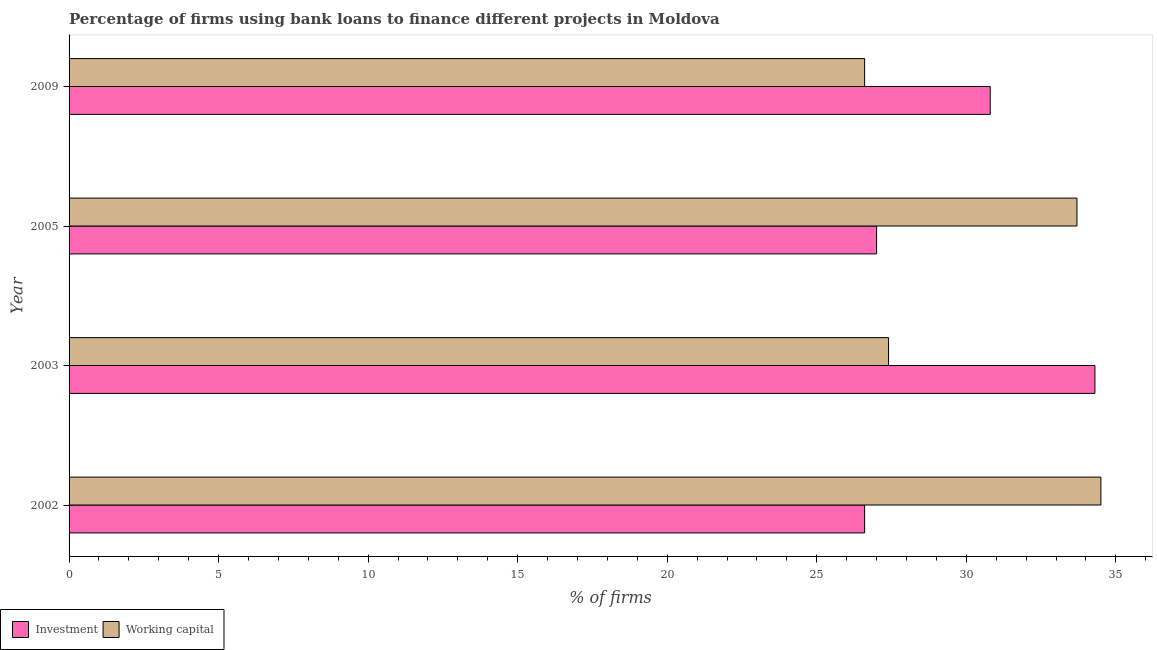How many groups of bars are there?
Offer a terse response. 4. How many bars are there on the 4th tick from the top?
Provide a short and direct response. 2. How many bars are there on the 1st tick from the bottom?
Give a very brief answer. 2. What is the label of the 2nd group of bars from the top?
Give a very brief answer. 2005. What is the percentage of firms using banks to finance working capital in 2002?
Make the answer very short. 34.5. Across all years, what is the maximum percentage of firms using banks to finance working capital?
Offer a very short reply. 34.5. Across all years, what is the minimum percentage of firms using banks to finance investment?
Offer a terse response. 26.6. In which year was the percentage of firms using banks to finance working capital minimum?
Your response must be concise. 2009. What is the total percentage of firms using banks to finance working capital in the graph?
Provide a succinct answer. 122.2. What is the difference between the percentage of firms using banks to finance working capital in 2002 and the percentage of firms using banks to finance investment in 2009?
Provide a short and direct response. 3.7. What is the average percentage of firms using banks to finance investment per year?
Your response must be concise. 29.68. In the year 2009, what is the difference between the percentage of firms using banks to finance working capital and percentage of firms using banks to finance investment?
Your response must be concise. -4.2. What is the ratio of the percentage of firms using banks to finance investment in 2002 to that in 2009?
Provide a succinct answer. 0.86. Is the difference between the percentage of firms using banks to finance investment in 2005 and 2009 greater than the difference between the percentage of firms using banks to finance working capital in 2005 and 2009?
Provide a succinct answer. No. What is the difference between the highest and the second highest percentage of firms using banks to finance working capital?
Your answer should be very brief. 0.8. In how many years, is the percentage of firms using banks to finance investment greater than the average percentage of firms using banks to finance investment taken over all years?
Offer a terse response. 2. What does the 1st bar from the top in 2009 represents?
Make the answer very short. Working capital. What does the 1st bar from the bottom in 2005 represents?
Give a very brief answer. Investment. Does the graph contain grids?
Your answer should be compact. No. Where does the legend appear in the graph?
Your response must be concise. Bottom left. What is the title of the graph?
Give a very brief answer. Percentage of firms using bank loans to finance different projects in Moldova. Does "Research and Development" appear as one of the legend labels in the graph?
Make the answer very short. No. What is the label or title of the X-axis?
Keep it short and to the point. % of firms. What is the label or title of the Y-axis?
Make the answer very short. Year. What is the % of firms in Investment in 2002?
Your answer should be compact. 26.6. What is the % of firms in Working capital in 2002?
Provide a short and direct response. 34.5. What is the % of firms of Investment in 2003?
Provide a short and direct response. 34.3. What is the % of firms in Working capital in 2003?
Your answer should be compact. 27.4. What is the % of firms in Investment in 2005?
Provide a succinct answer. 27. What is the % of firms in Working capital in 2005?
Keep it short and to the point. 33.7. What is the % of firms of Investment in 2009?
Give a very brief answer. 30.8. What is the % of firms in Working capital in 2009?
Make the answer very short. 26.6. Across all years, what is the maximum % of firms of Investment?
Offer a terse response. 34.3. Across all years, what is the maximum % of firms in Working capital?
Your response must be concise. 34.5. Across all years, what is the minimum % of firms in Investment?
Provide a short and direct response. 26.6. Across all years, what is the minimum % of firms in Working capital?
Offer a very short reply. 26.6. What is the total % of firms of Investment in the graph?
Keep it short and to the point. 118.7. What is the total % of firms of Working capital in the graph?
Your answer should be very brief. 122.2. What is the difference between the % of firms of Investment in 2002 and that in 2003?
Give a very brief answer. -7.7. What is the difference between the % of firms in Investment in 2002 and that in 2005?
Your answer should be compact. -0.4. What is the difference between the % of firms of Working capital in 2002 and that in 2005?
Provide a short and direct response. 0.8. What is the difference between the % of firms of Investment in 2002 and that in 2009?
Ensure brevity in your answer.  -4.2. What is the difference between the % of firms of Investment in 2003 and that in 2005?
Make the answer very short. 7.3. What is the difference between the % of firms of Working capital in 2003 and that in 2005?
Ensure brevity in your answer.  -6.3. What is the difference between the % of firms of Working capital in 2003 and that in 2009?
Provide a succinct answer. 0.8. What is the difference between the % of firms in Investment in 2005 and that in 2009?
Make the answer very short. -3.8. What is the difference between the % of firms of Working capital in 2005 and that in 2009?
Keep it short and to the point. 7.1. What is the difference between the % of firms of Investment in 2002 and the % of firms of Working capital in 2003?
Provide a succinct answer. -0.8. What is the difference between the % of firms of Investment in 2002 and the % of firms of Working capital in 2005?
Your response must be concise. -7.1. What is the average % of firms of Investment per year?
Provide a succinct answer. 29.68. What is the average % of firms in Working capital per year?
Your answer should be compact. 30.55. In the year 2002, what is the difference between the % of firms in Investment and % of firms in Working capital?
Offer a terse response. -7.9. In the year 2009, what is the difference between the % of firms of Investment and % of firms of Working capital?
Ensure brevity in your answer.  4.2. What is the ratio of the % of firms in Investment in 2002 to that in 2003?
Make the answer very short. 0.78. What is the ratio of the % of firms in Working capital in 2002 to that in 2003?
Give a very brief answer. 1.26. What is the ratio of the % of firms in Investment in 2002 to that in 2005?
Offer a very short reply. 0.99. What is the ratio of the % of firms of Working capital in 2002 to that in 2005?
Your response must be concise. 1.02. What is the ratio of the % of firms of Investment in 2002 to that in 2009?
Ensure brevity in your answer.  0.86. What is the ratio of the % of firms in Working capital in 2002 to that in 2009?
Offer a very short reply. 1.3. What is the ratio of the % of firms in Investment in 2003 to that in 2005?
Offer a terse response. 1.27. What is the ratio of the % of firms of Working capital in 2003 to that in 2005?
Make the answer very short. 0.81. What is the ratio of the % of firms in Investment in 2003 to that in 2009?
Ensure brevity in your answer.  1.11. What is the ratio of the % of firms of Working capital in 2003 to that in 2009?
Make the answer very short. 1.03. What is the ratio of the % of firms in Investment in 2005 to that in 2009?
Provide a short and direct response. 0.88. What is the ratio of the % of firms in Working capital in 2005 to that in 2009?
Keep it short and to the point. 1.27. What is the difference between the highest and the second highest % of firms in Investment?
Ensure brevity in your answer.  3.5. What is the difference between the highest and the second highest % of firms in Working capital?
Offer a very short reply. 0.8. What is the difference between the highest and the lowest % of firms of Investment?
Your response must be concise. 7.7. 